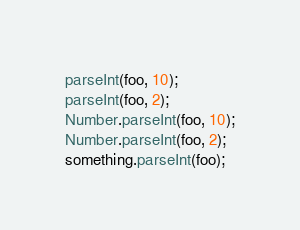<code> <loc_0><loc_0><loc_500><loc_500><_JavaScript_>parseInt(foo, 10);
parseInt(foo, 2);
Number.parseInt(foo, 10);
Number.parseInt(foo, 2);
something.parseInt(foo);
</code> 